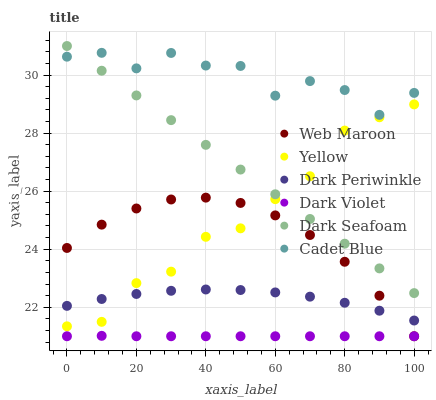Does Dark Violet have the minimum area under the curve?
Answer yes or no. Yes. Does Cadet Blue have the maximum area under the curve?
Answer yes or no. Yes. Does Web Maroon have the minimum area under the curve?
Answer yes or no. No. Does Web Maroon have the maximum area under the curve?
Answer yes or no. No. Is Dark Seafoam the smoothest?
Answer yes or no. Yes. Is Cadet Blue the roughest?
Answer yes or no. Yes. Is Web Maroon the smoothest?
Answer yes or no. No. Is Web Maroon the roughest?
Answer yes or no. No. Does Web Maroon have the lowest value?
Answer yes or no. Yes. Does Dark Seafoam have the lowest value?
Answer yes or no. No. Does Dark Seafoam have the highest value?
Answer yes or no. Yes. Does Web Maroon have the highest value?
Answer yes or no. No. Is Dark Violet less than Dark Periwinkle?
Answer yes or no. Yes. Is Cadet Blue greater than Web Maroon?
Answer yes or no. Yes. Does Web Maroon intersect Yellow?
Answer yes or no. Yes. Is Web Maroon less than Yellow?
Answer yes or no. No. Is Web Maroon greater than Yellow?
Answer yes or no. No. Does Dark Violet intersect Dark Periwinkle?
Answer yes or no. No. 